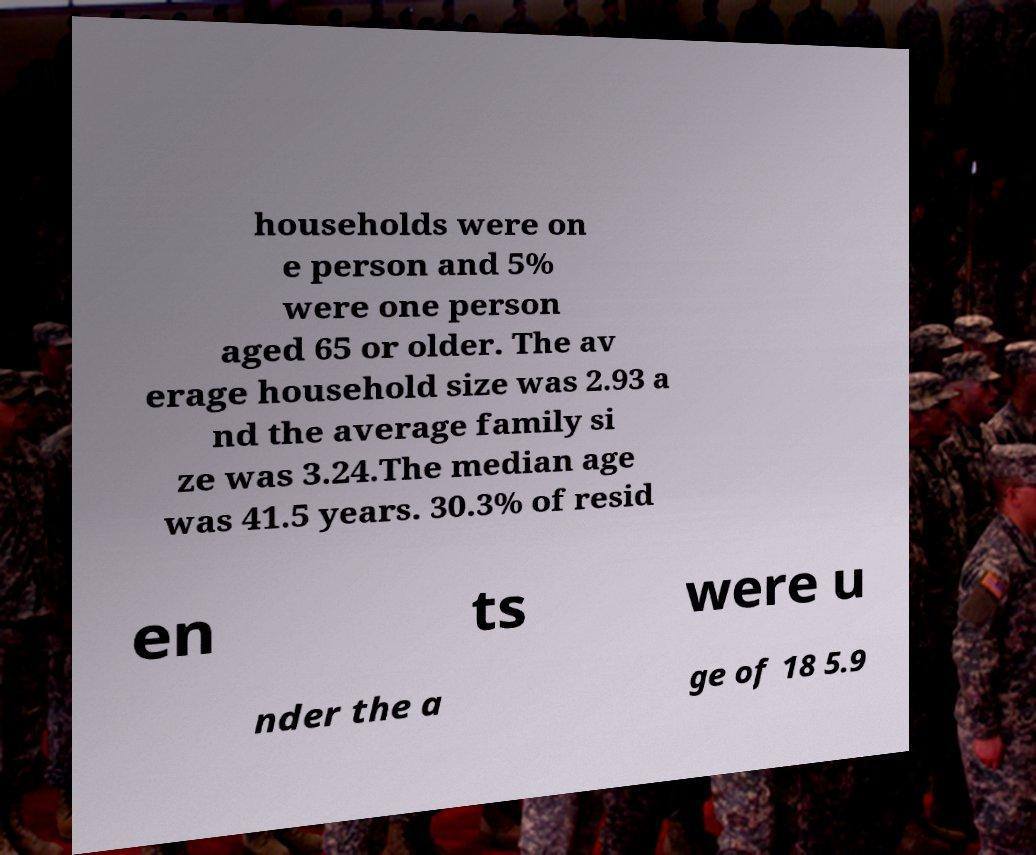Please identify and transcribe the text found in this image. households were on e person and 5% were one person aged 65 or older. The av erage household size was 2.93 a nd the average family si ze was 3.24.The median age was 41.5 years. 30.3% of resid en ts were u nder the a ge of 18 5.9 